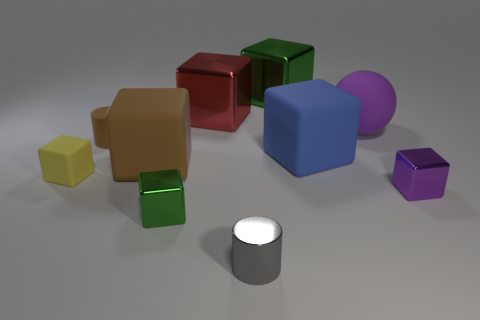There is a cylinder that is behind the tiny purple thing; what number of big purple rubber things are behind it? 1 